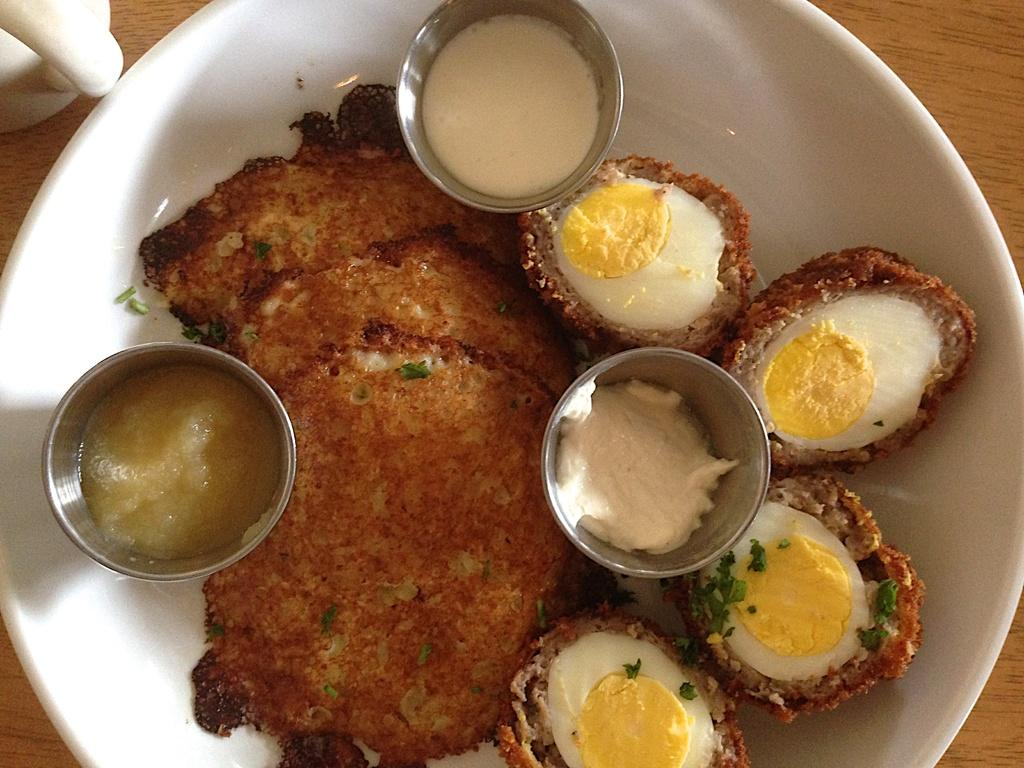What type of food item is visible in the image? There is a food item in the image, but the specific type is not mentioned in the facts. What is placed on the plate in the image? There are balls on a plate in the image. Where is the plate located? The plate is on a table in the image. What else can be seen on the table? There is a cup in the image. Can you describe the smile on the food item in the image? There is no smile present on the food item in the image, as it is an inanimate object. 